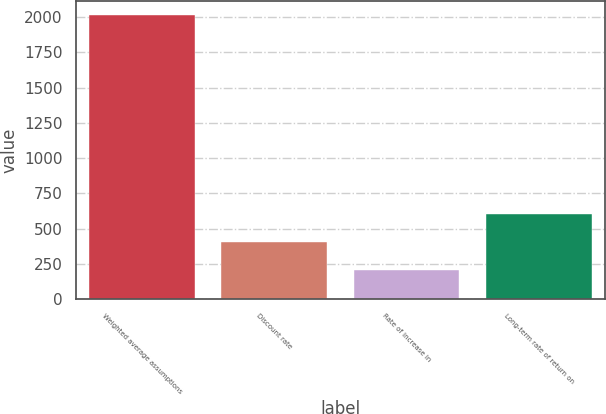Convert chart to OTSL. <chart><loc_0><loc_0><loc_500><loc_500><bar_chart><fcel>Weighted average assumptions<fcel>Discount rate<fcel>Rate of increase in<fcel>Long-term rate of return on<nl><fcel>2011<fcel>405.61<fcel>204.93<fcel>606.29<nl></chart> 